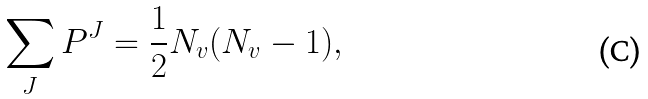<formula> <loc_0><loc_0><loc_500><loc_500>\sum _ { J } P ^ { J } = \frac { 1 } { 2 } N _ { v } ( N _ { v } - 1 ) ,</formula> 